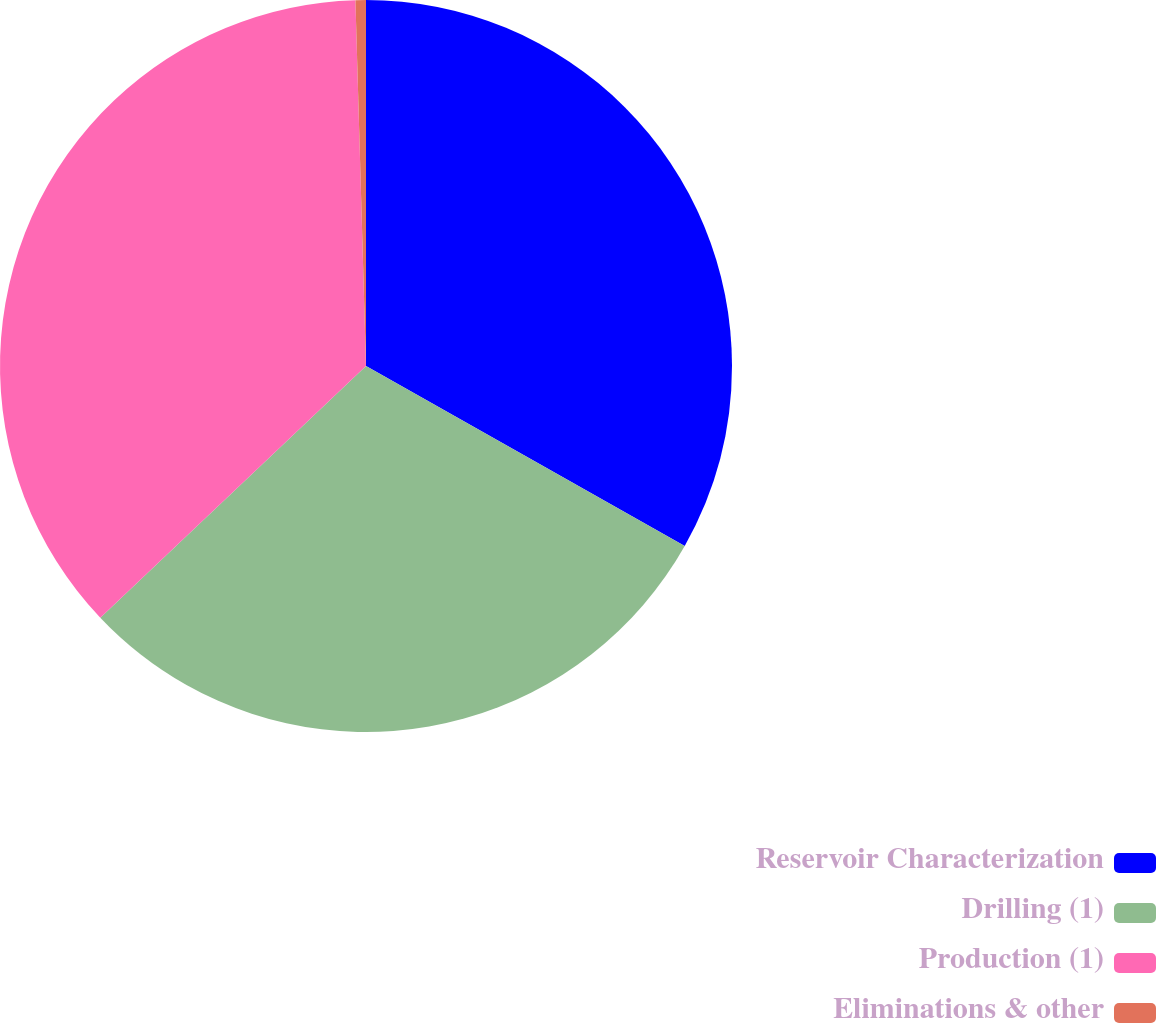Convert chart to OTSL. <chart><loc_0><loc_0><loc_500><loc_500><pie_chart><fcel>Reservoir Characterization<fcel>Drilling (1)<fcel>Production (1)<fcel>Eliminations & other<nl><fcel>33.18%<fcel>29.75%<fcel>36.61%<fcel>0.46%<nl></chart> 